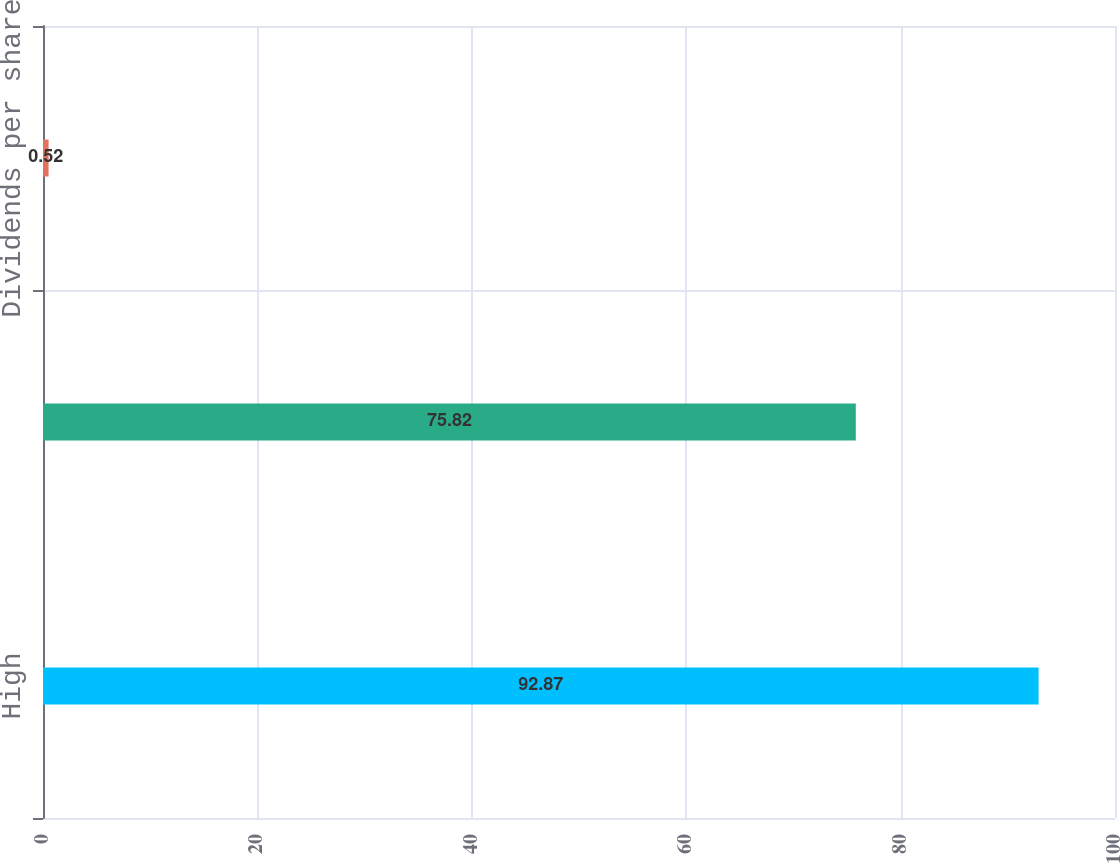<chart> <loc_0><loc_0><loc_500><loc_500><bar_chart><fcel>High<fcel>Low<fcel>Dividends per share<nl><fcel>92.87<fcel>75.82<fcel>0.52<nl></chart> 